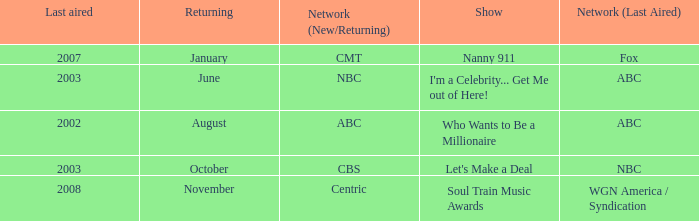What show was played on ABC laster after 2002? I'm a Celebrity... Get Me out of Here!. 